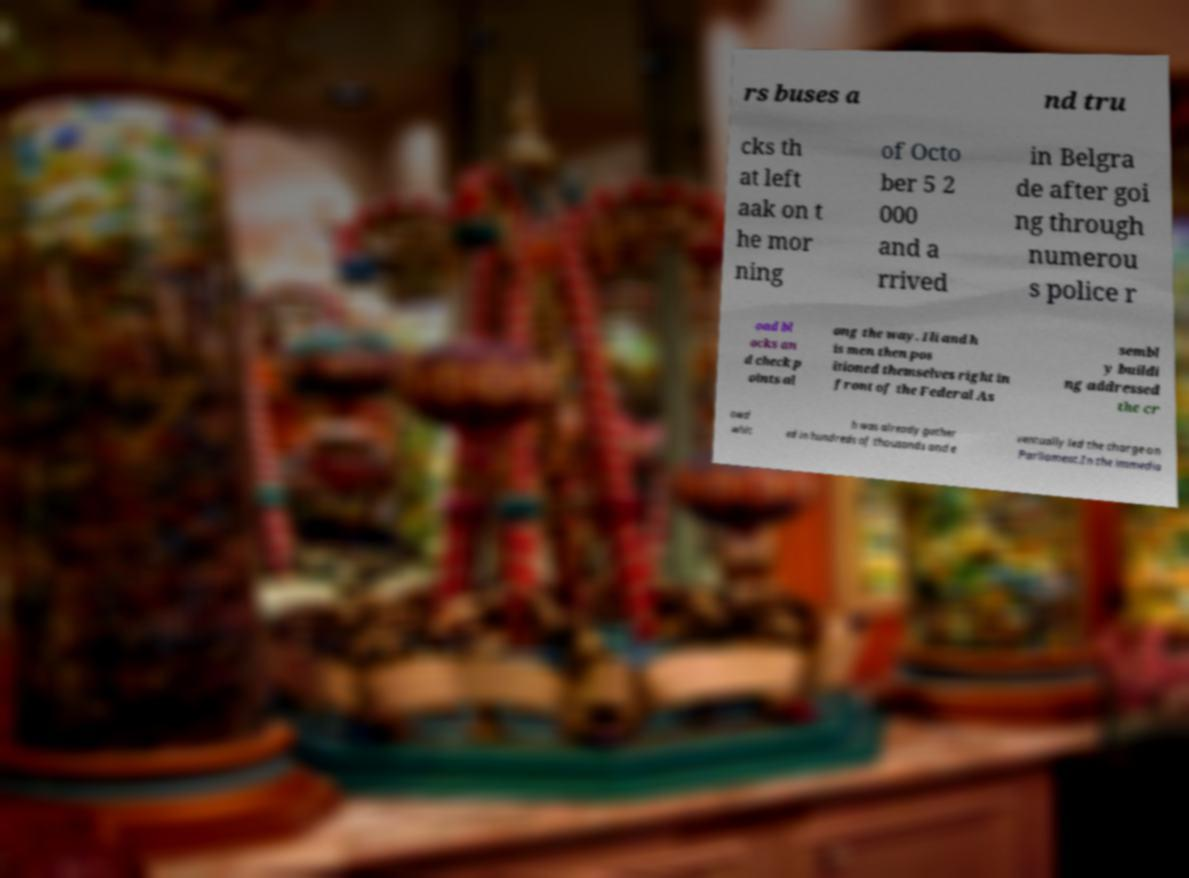There's text embedded in this image that I need extracted. Can you transcribe it verbatim? rs buses a nd tru cks th at left aak on t he mor ning of Octo ber 5 2 000 and a rrived in Belgra de after goi ng through numerou s police r oad bl ocks an d check p oints al ong the way. Ili and h is men then pos itioned themselves right in front of the Federal As sembl y buildi ng addressed the cr owd whic h was already gather ed in hundreds of thousands and e ventually led the charge on Parliament.In the immedia 